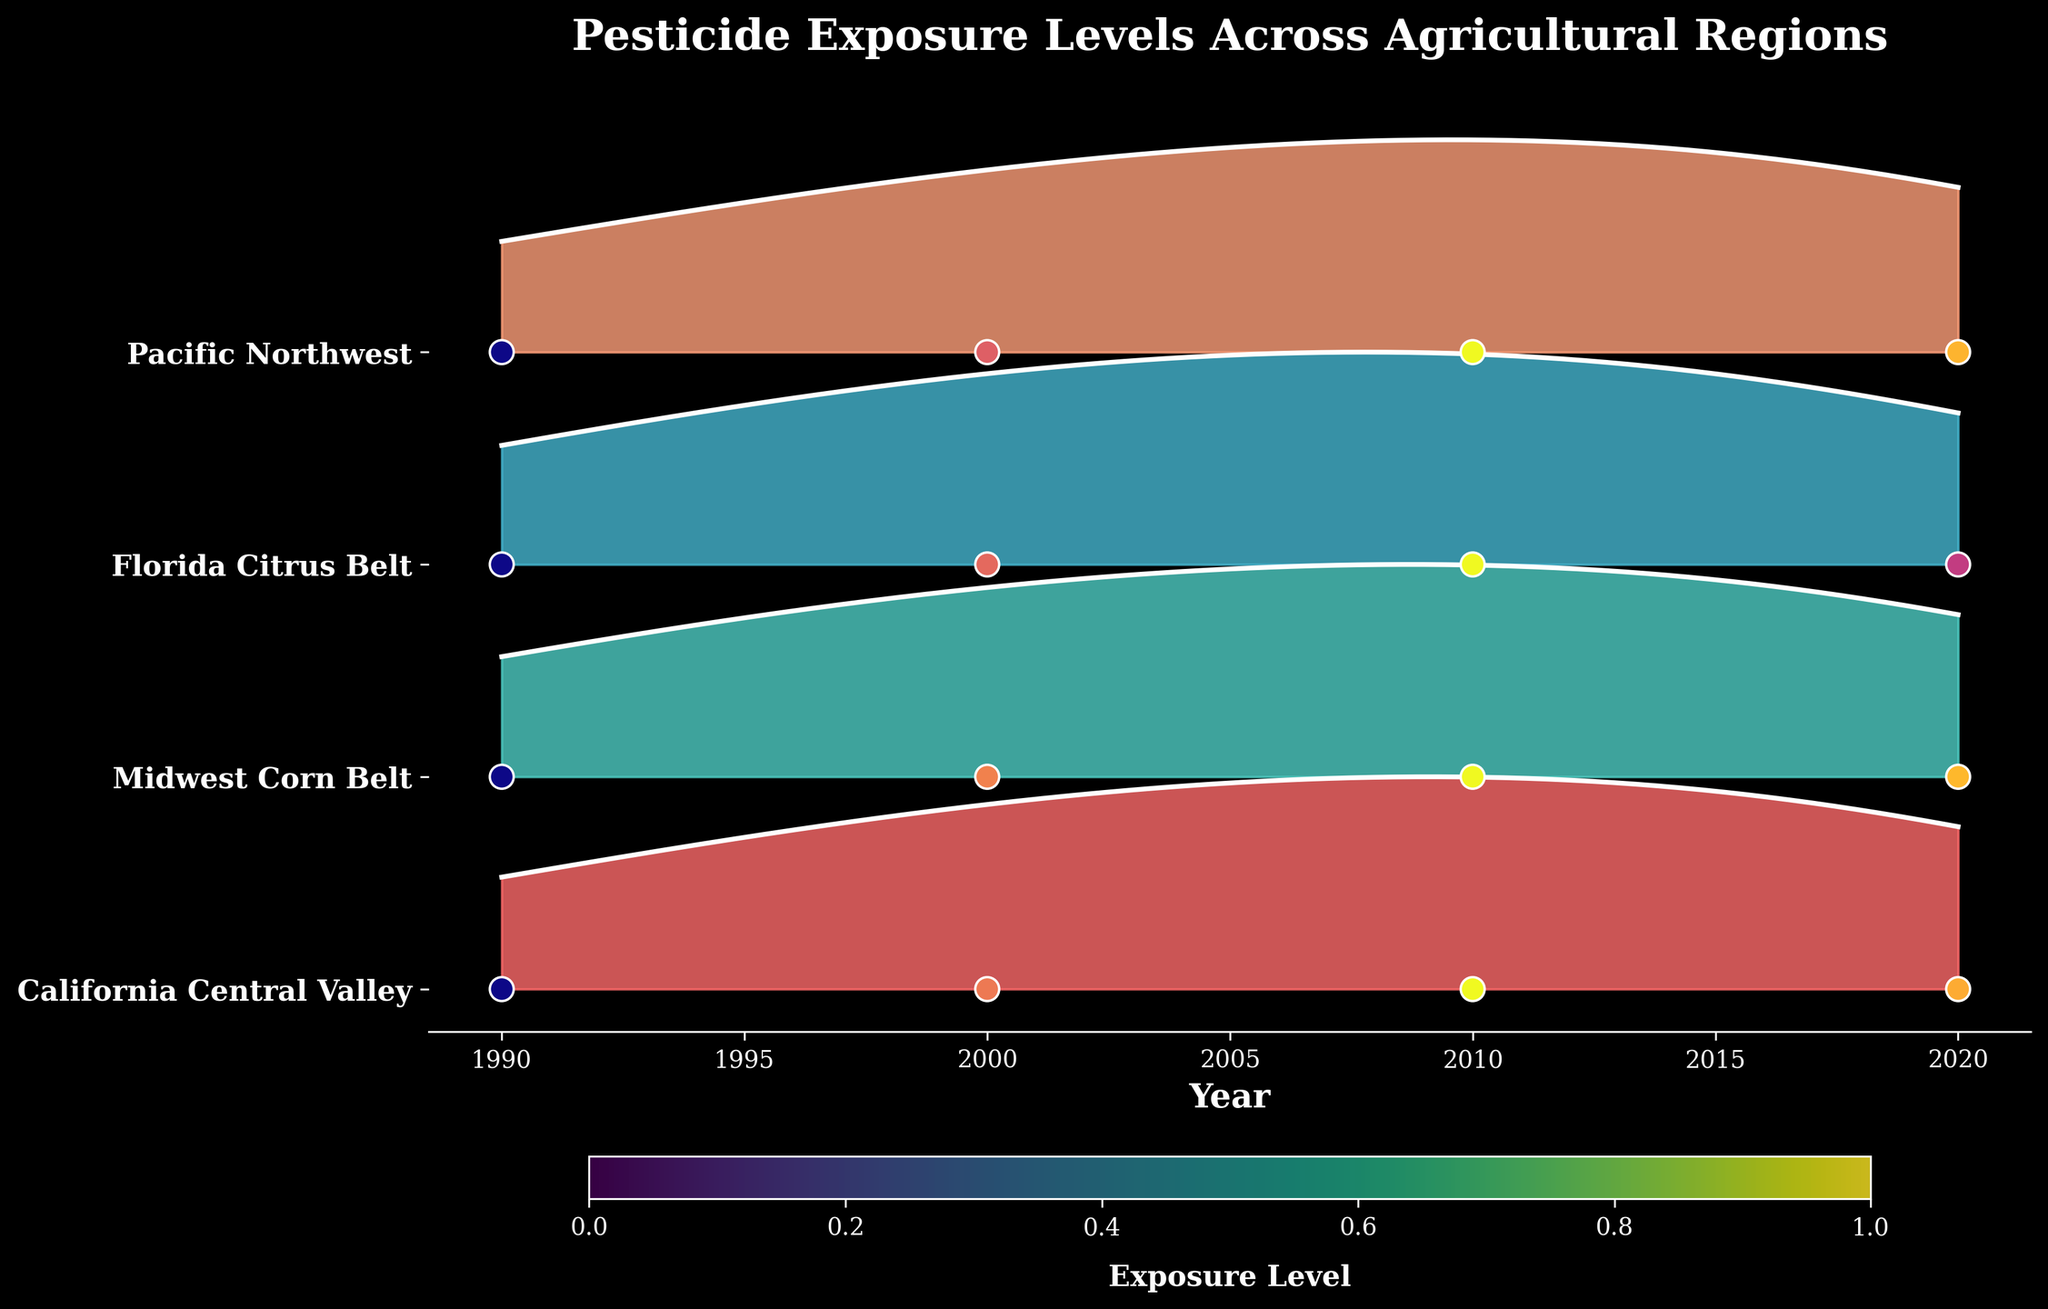What is the title of the plot? The title is usually at the top of the plot and describes the content of the figure.
Answer: Pesticide Exposure Levels Across Agricultural Regions How many regions are represented in the plot? The regions are listed on the y-axis of the plot, each represented by a different line.
Answer: 4 Which region has the highest exposure level in 2020? Look for the region whose scatter point for the year 2020 is placed the highest in the figure.
Answer: California Central Valley What is the general trend of pesticide exposure in the California Central Valley from 1990 to 2020? Observe the direction of the line for the California Central Valley through the years 1990 to 2020 to determine if it is increasing, decreasing, or remaining constant.
Answer: Increasing, then slightly decreasing in 2020 Which region had the lowest exposure level in 1990? Compare the scatter points for 1990 across all regions and identify the one at the lowest position.
Answer: Pacific Northwest What is the approximate change in exposure levels for Atrazine in the Midwest Corn Belt from 1990 to 2020? Subtract the exposure level in 1990 from the exposure level in 2020 for Atrazine in the Midwest Corn Belt.
Answer: 1.1 (2.9 - 1.8) Which two regions show the most similar trend in exposure levels over time? Compare the shapes of the lines for different regions to identify two with similar trends.
Answer: Midwest Corn Belt and Pacific Northwest By how much did the exposure level of Chlorpyrifos in the Florida Citrus Belt change from 2010 to 2020? Subtract the exposure level in 2010 from the exposure level in 2020 for Chlorpyrifos in the Florida Citrus Belt.
Answer: -0.7 (2.1 - 2.8) What is the color of the line representing exposure levels in the California Central Valley? The color of the line can be observed visually; it should correspond to a unique color among the plotted lines.
Answer: A shade of red If the trend of Malathion in the Pacific Northwest continued past 2020, would you expect the exposure levels to increase or decrease? Why? Observe the slope of the line for Malathion in the Pacific Northwest towards the end and follow the trajectory logically.
Answer: Decrease, based on the downward trend in 2020 